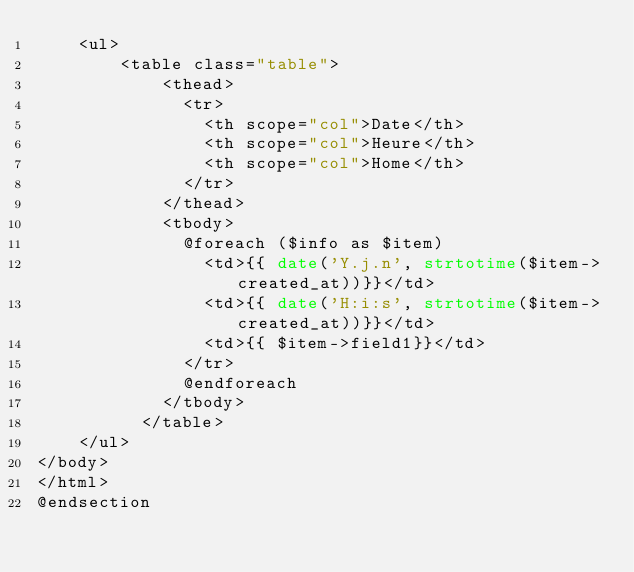Convert code to text. <code><loc_0><loc_0><loc_500><loc_500><_PHP_>    <ul>
        <table class="table">
            <thead>
              <tr>
                <th scope="col">Date</th>
                <th scope="col">Heure</th>
                <th scope="col">Home</th>
              </tr>
            </thead>
            <tbody>
              @foreach ($info as $item)
                <td>{{ date('Y.j.n', strtotime($item->created_at))}}</td>
                <td>{{ date('H:i:s', strtotime($item->created_at))}}</td>
                <td>{{ $item->field1}}</td>
              </tr>
              @endforeach
            </tbody>
          </table>
    </ul>
</body>
</html>
@endsection</code> 